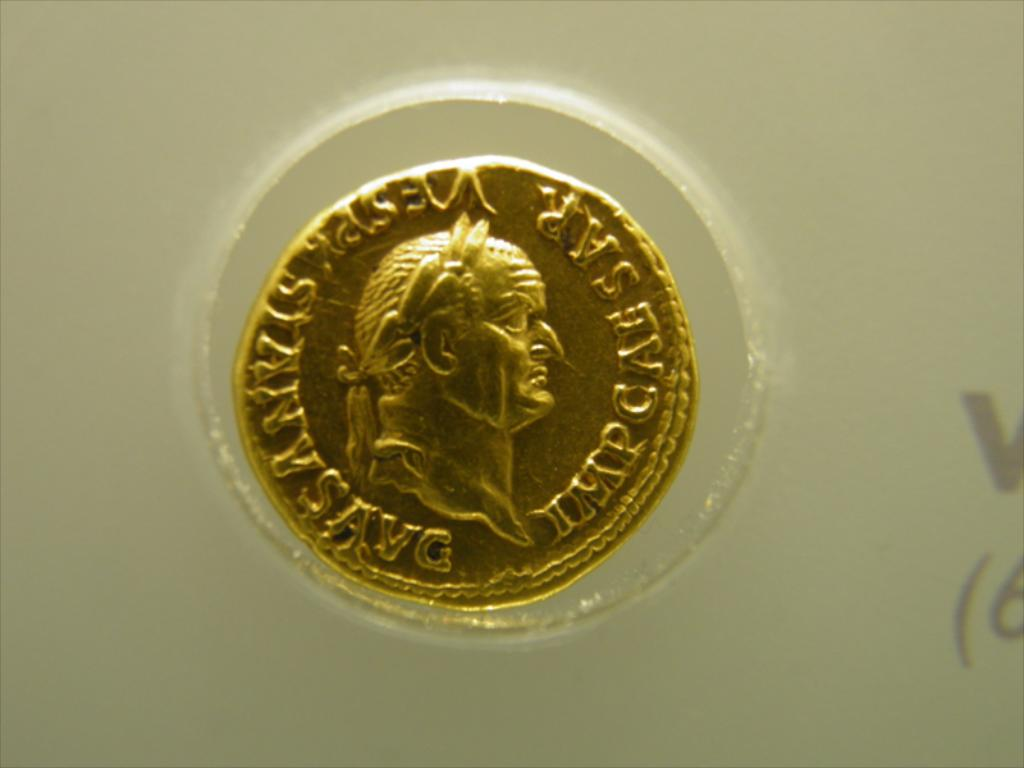What can you infer about the era or origin of this coin based on its design? The coin's design, featuring a detailed relief portrait and the classic use of Latin lettering, suggests it originates from an era where such artistry in coinage was prevalent, likely during the Roman Empire or inspired by it, reflecting historical significance and craftsmanship. 